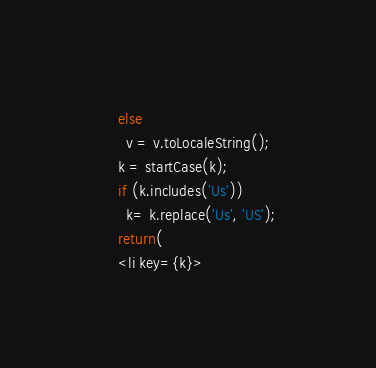<code> <loc_0><loc_0><loc_500><loc_500><_JavaScript_>    else
      v = v.toLocaleString();
    k = startCase(k);
    if (k.includes('Us'))
      k= k.replace('Us', 'US');
    return(
    <li key={k}></code> 